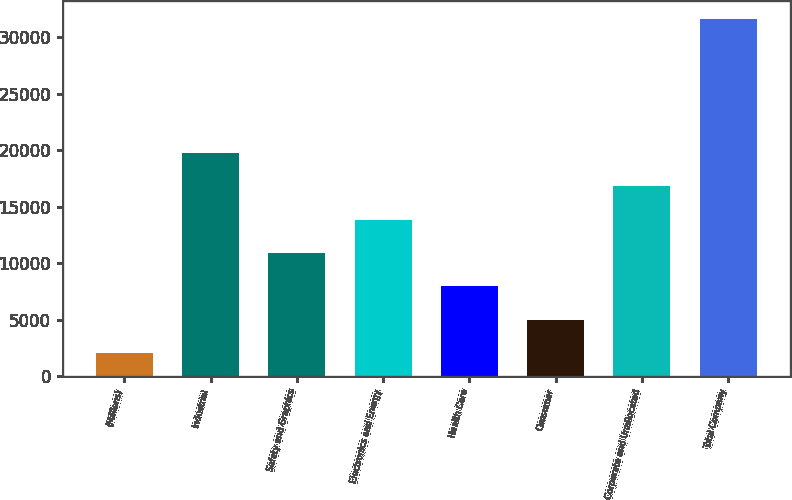Convert chart to OTSL. <chart><loc_0><loc_0><loc_500><loc_500><bar_chart><fcel>(Millions)<fcel>Industrial<fcel>Safety and Graphics<fcel>Electronics and Energy<fcel>Health Care<fcel>Consumer<fcel>Corporate and Unallocated<fcel>Total Company<nl><fcel>2011<fcel>19774<fcel>10892.5<fcel>13853<fcel>7932<fcel>4971.5<fcel>16813.5<fcel>31616<nl></chart> 